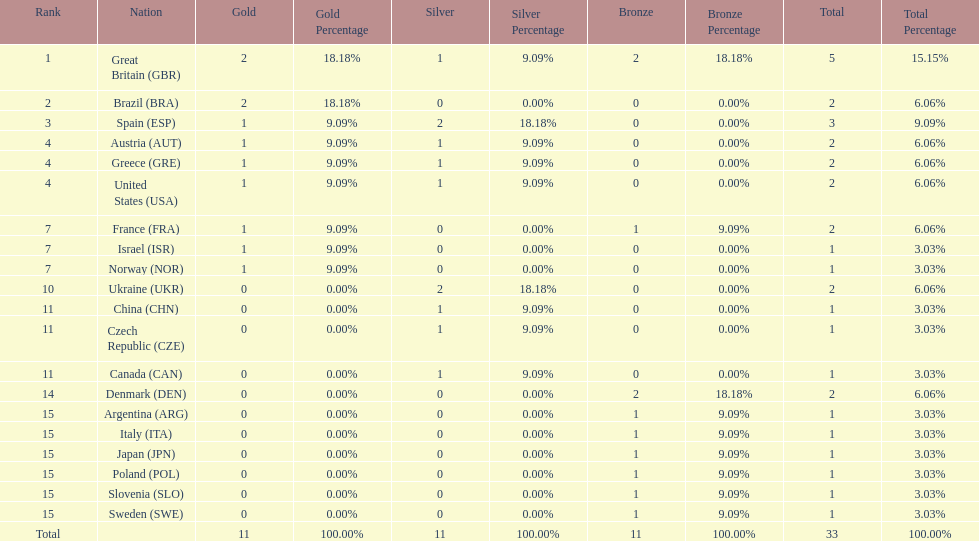How many gold medals did italy receive? 0. 